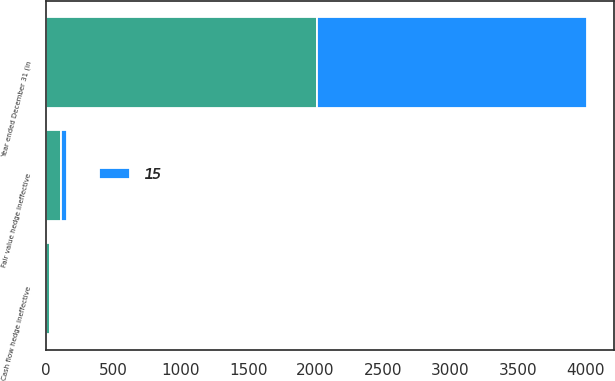Convert chart to OTSL. <chart><loc_0><loc_0><loc_500><loc_500><stacked_bar_chart><ecel><fcel>Year ended December 31 (in<fcel>Fair value hedge ineffective<fcel>Cash flow hedge ineffective<nl><fcel>nan<fcel>2007<fcel>111<fcel>29<nl><fcel>15<fcel>2006<fcel>51<fcel>2<nl></chart> 